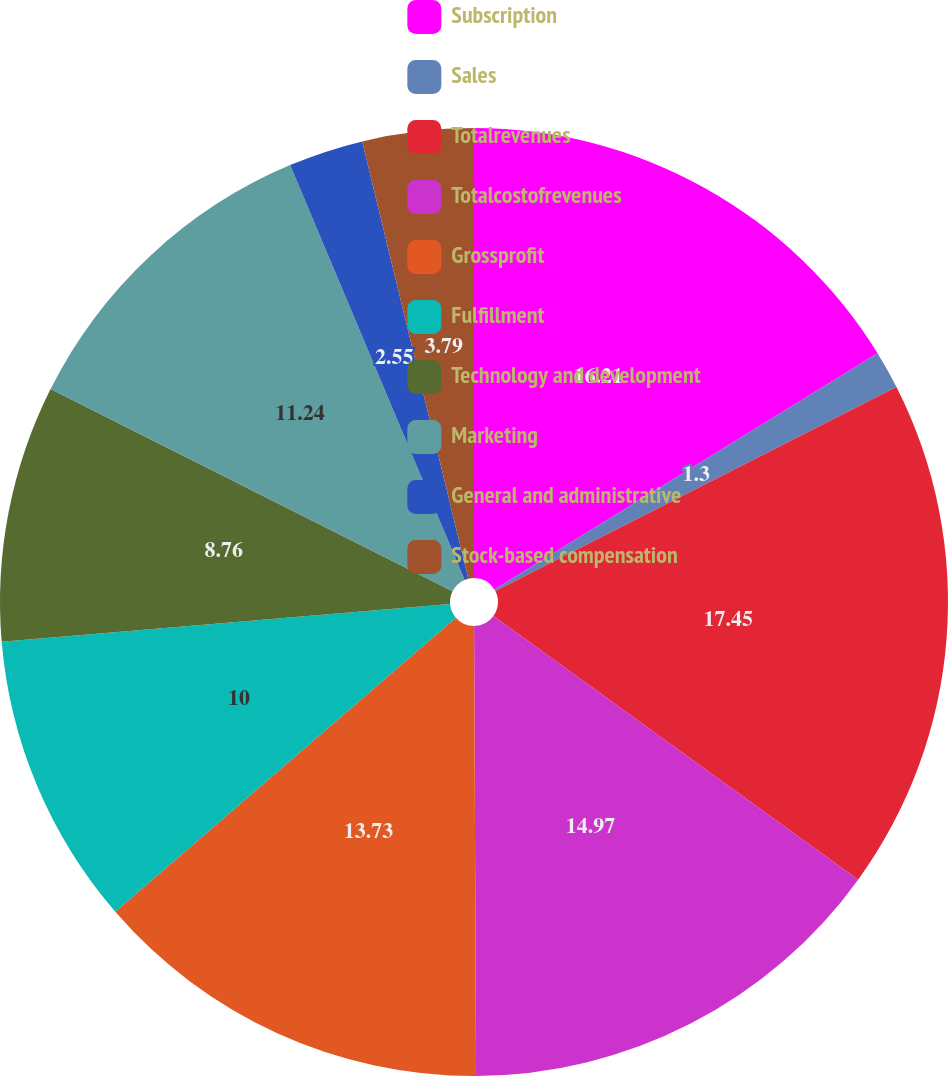Convert chart. <chart><loc_0><loc_0><loc_500><loc_500><pie_chart><fcel>Subscription<fcel>Sales<fcel>Totalrevenues<fcel>Totalcostofrevenues<fcel>Grossprofit<fcel>Fulfillment<fcel>Technology and development<fcel>Marketing<fcel>General and administrative<fcel>Stock-based compensation<nl><fcel>16.21%<fcel>1.3%<fcel>17.45%<fcel>14.97%<fcel>13.73%<fcel>10.0%<fcel>8.76%<fcel>11.24%<fcel>2.55%<fcel>3.79%<nl></chart> 